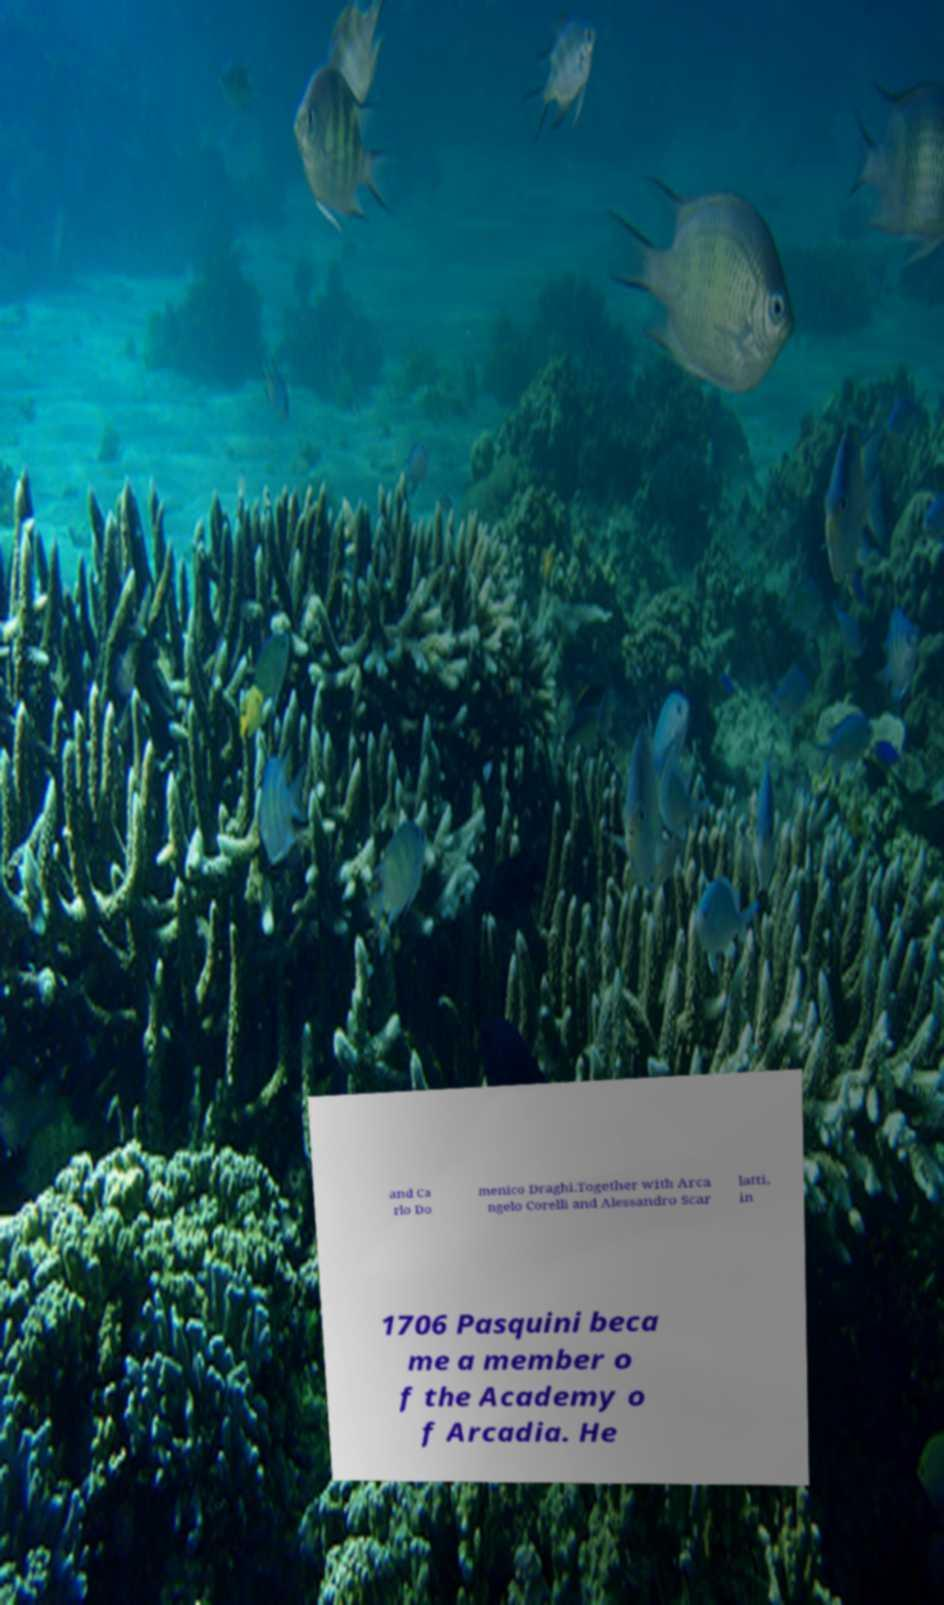Could you assist in decoding the text presented in this image and type it out clearly? and Ca rlo Do menico Draghi.Together with Arca ngelo Corelli and Alessandro Scar latti, in 1706 Pasquini beca me a member o f the Academy o f Arcadia. He 